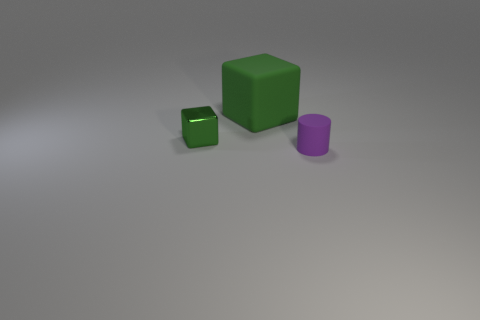Add 1 large blue things. How many objects exist? 4 Add 1 large green matte objects. How many large green matte objects are left? 2 Add 1 matte cubes. How many matte cubes exist? 2 Subtract 0 brown cylinders. How many objects are left? 3 Subtract all cylinders. How many objects are left? 2 Subtract all green things. Subtract all rubber blocks. How many objects are left? 0 